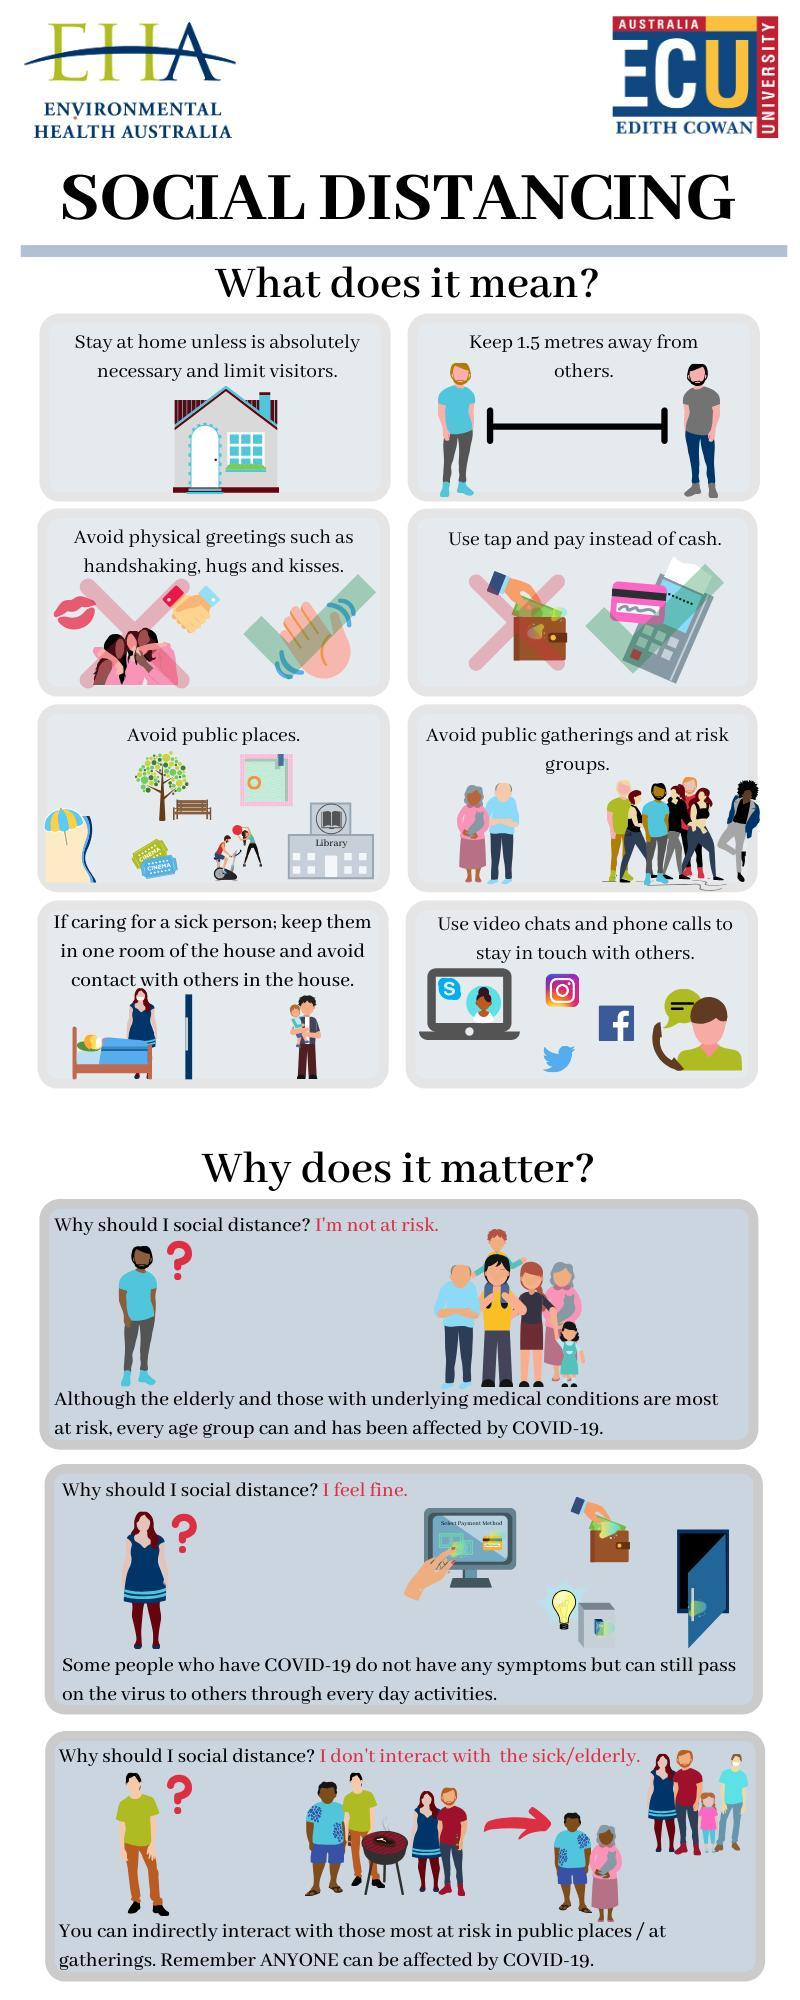What is the safe distance to be maintained between one another as a part of social distancing?
Answer the question with a short phrase. 1.5 metres 